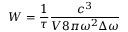Convert formula to latex. <formula><loc_0><loc_0><loc_500><loc_500>W = \frac { 1 } { \tau } \frac { c ^ { 3 } } { V 8 \pi \omega ^ { 2 } \Delta \omega }</formula> 